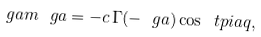Convert formula to latex. <formula><loc_0><loc_0><loc_500><loc_500>\ g a m ^ { \ } g a = - c \, \Gamma ( - \ g a ) \cos \ t p i a q ,</formula> 